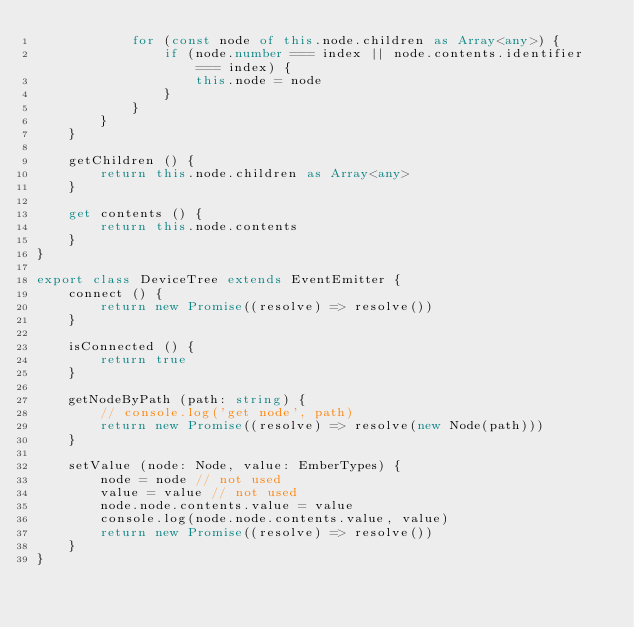Convert code to text. <code><loc_0><loc_0><loc_500><loc_500><_TypeScript_>			for (const node of this.node.children as Array<any>) {
				if (node.number === index || node.contents.identifier === index) {
					this.node = node
				}
			}
		}
	}

	getChildren () {
		return this.node.children as Array<any>
	}

	get contents () {
		return this.node.contents
	}
}

export class DeviceTree extends EventEmitter {
	connect () {
		return new Promise((resolve) => resolve())
	}

	isConnected () {
		return true
	}

	getNodeByPath (path: string) {
		// console.log('get node', path)
		return new Promise((resolve) => resolve(new Node(path)))
	}

	setValue (node: Node, value: EmberTypes) {
		node = node // not used
		value = value // not used
		node.node.contents.value = value
		console.log(node.node.contents.value, value)
		return new Promise((resolve) => resolve())
	}
}
</code> 